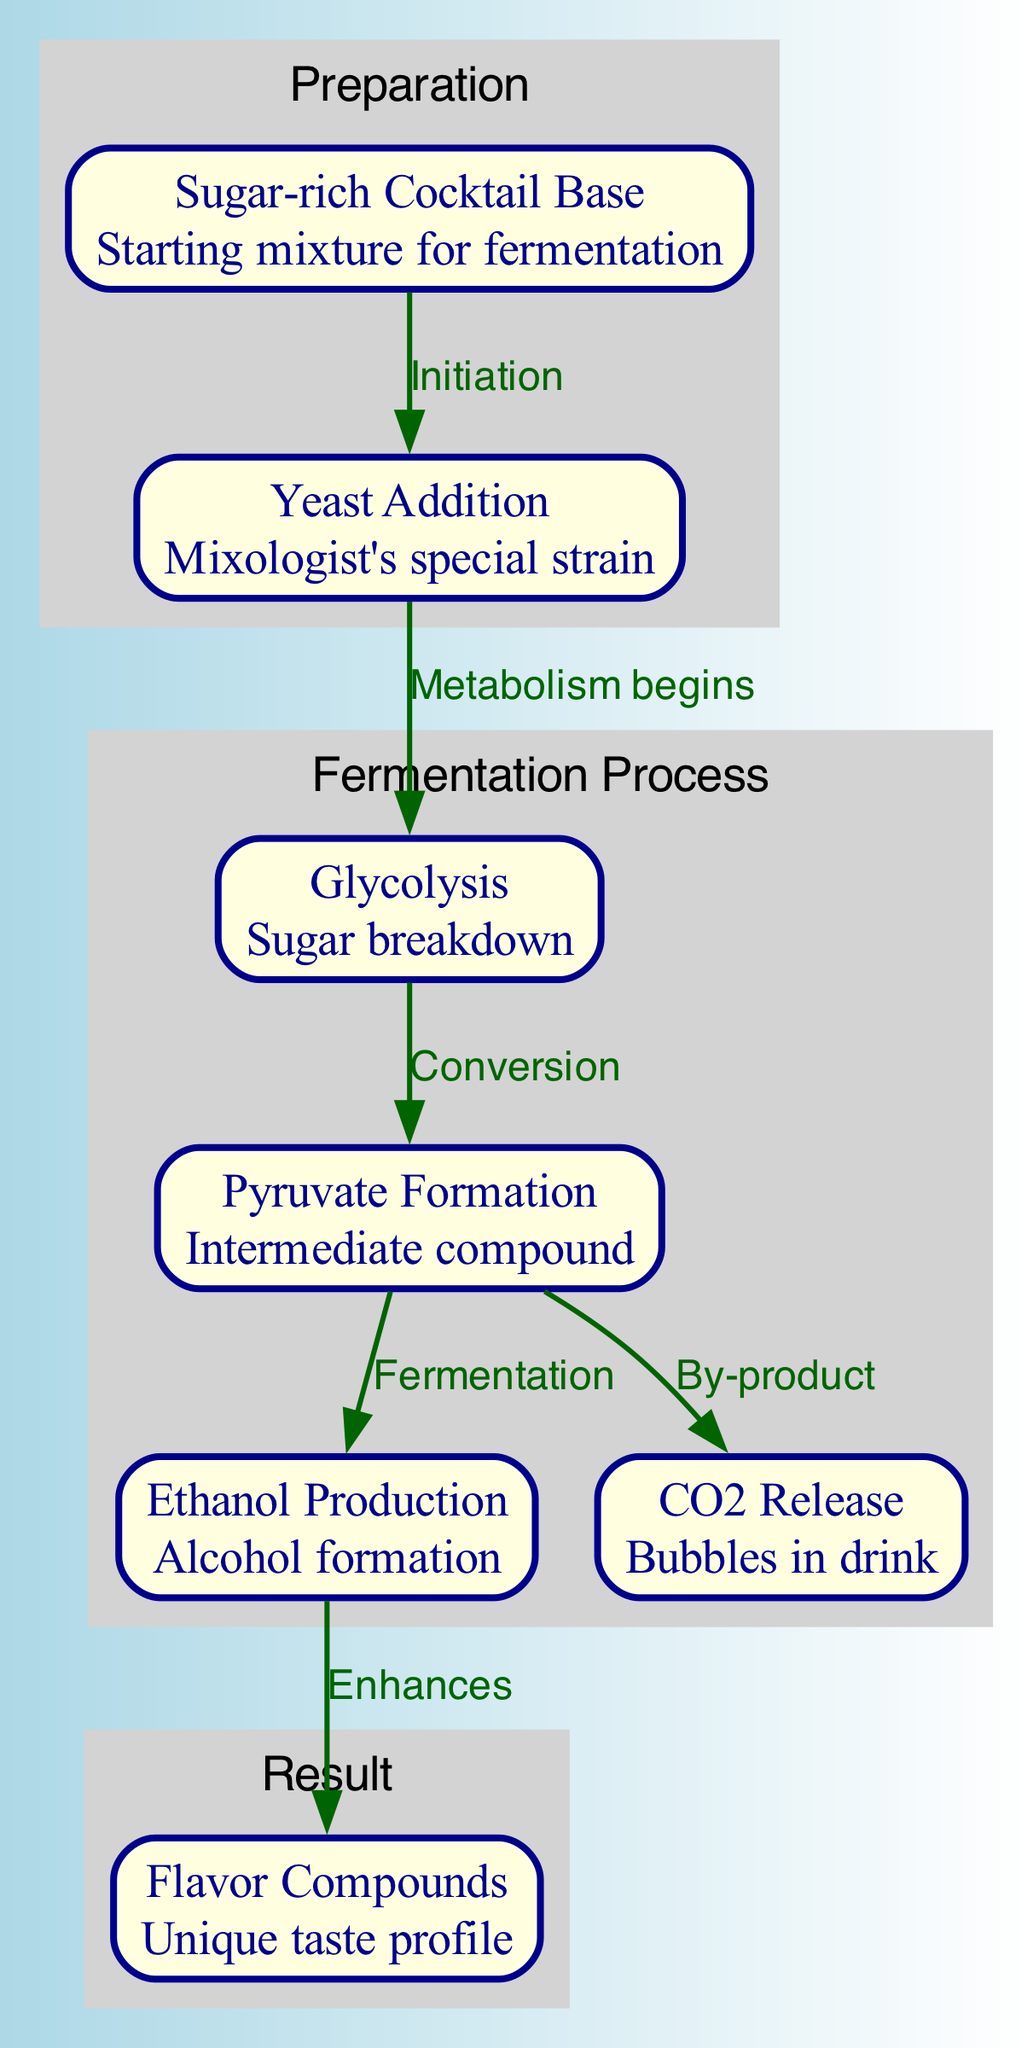What's the starting mixture for fermentation? The diagram indicates that the starting mixture for fermentation is labeled as "Sugar-rich Cocktail Base". This is the first node in the fermentation process.
Answer: Sugar-rich Cocktail Base How many stages are involved in the fermentation process? The diagram has a total of five nodes that represent different stages in the fermentation process, indicating five distinct stages from sugar to flavor compounds.
Answer: 5 What is produced from pyruvate during fermentation? The diagram shows that pyruvate leads to "Ethanol Production", which is the conversion of pyruvate into alcohol during fermentation.
Answer: Ethanol Production What is released as a by-product during fermentation? The process outlined in the diagram shows that a by-product of fermentation is "CO2 Release", which corresponds to the bubbles in the drink, illustrating another outcome of the fermentation process.
Answer: CO2 Release What enhances the unique taste profile after ethanol production? In the diagram, the edge from "Ethanol Production" to "Flavor Compounds" indicates that the production of ethanol enhances the unique taste profile of the cocktail, showing how the alcohol influences flavor.
Answer: Enhances 